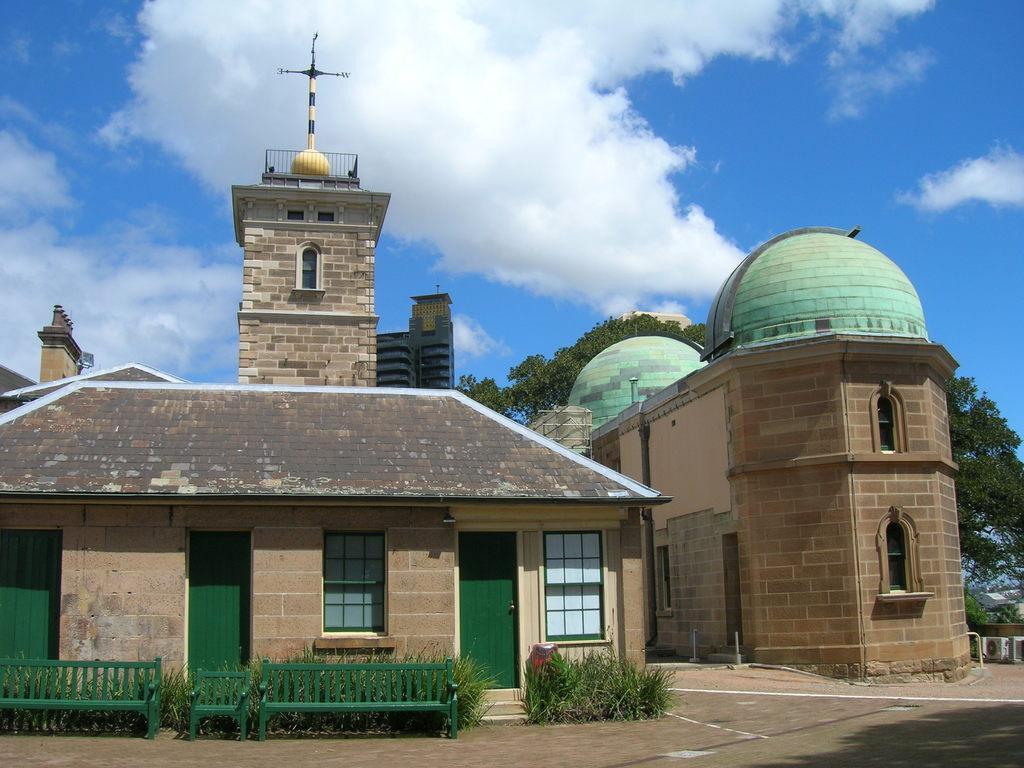In one or two sentences, can you explain what this image depicts? This is an outside view. Here I can see few buildings. In front of the building there are some plants and few benches are placed on the ground. In the background there are some trees. At the top I can see the sky and clouds. 